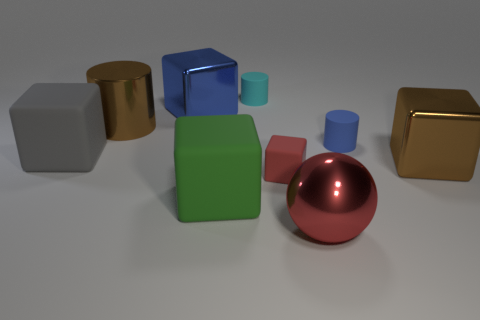Subtract all yellow cubes. Subtract all brown cylinders. How many cubes are left? 5 Subtract all cylinders. How many objects are left? 6 Add 3 matte objects. How many matte objects exist? 8 Subtract 0 yellow spheres. How many objects are left? 9 Subtract all red metallic spheres. Subtract all blue matte cylinders. How many objects are left? 7 Add 1 tiny blue matte cylinders. How many tiny blue matte cylinders are left? 2 